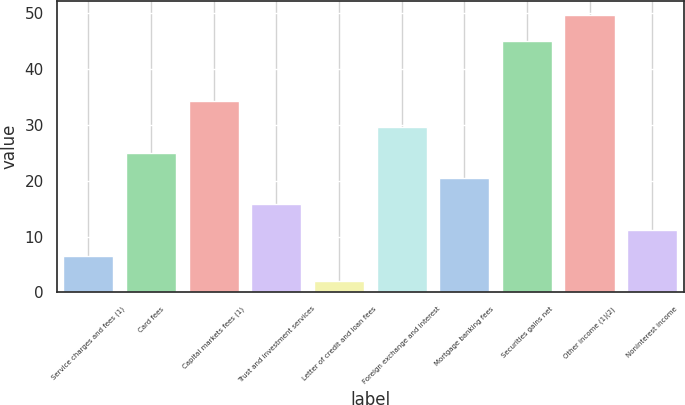Convert chart to OTSL. <chart><loc_0><loc_0><loc_500><loc_500><bar_chart><fcel>Service charges and fees (1)<fcel>Card fees<fcel>Capital markets fees (1)<fcel>Trust and investment services<fcel>Letter of credit and loan fees<fcel>Foreign exchange and interest<fcel>Mortgage banking fees<fcel>Securities gains net<fcel>Other income (1)(2)<fcel>Noninterest income<nl><fcel>6.6<fcel>25<fcel>34.2<fcel>15.8<fcel>2<fcel>29.6<fcel>20.4<fcel>45<fcel>49.6<fcel>11.2<nl></chart> 